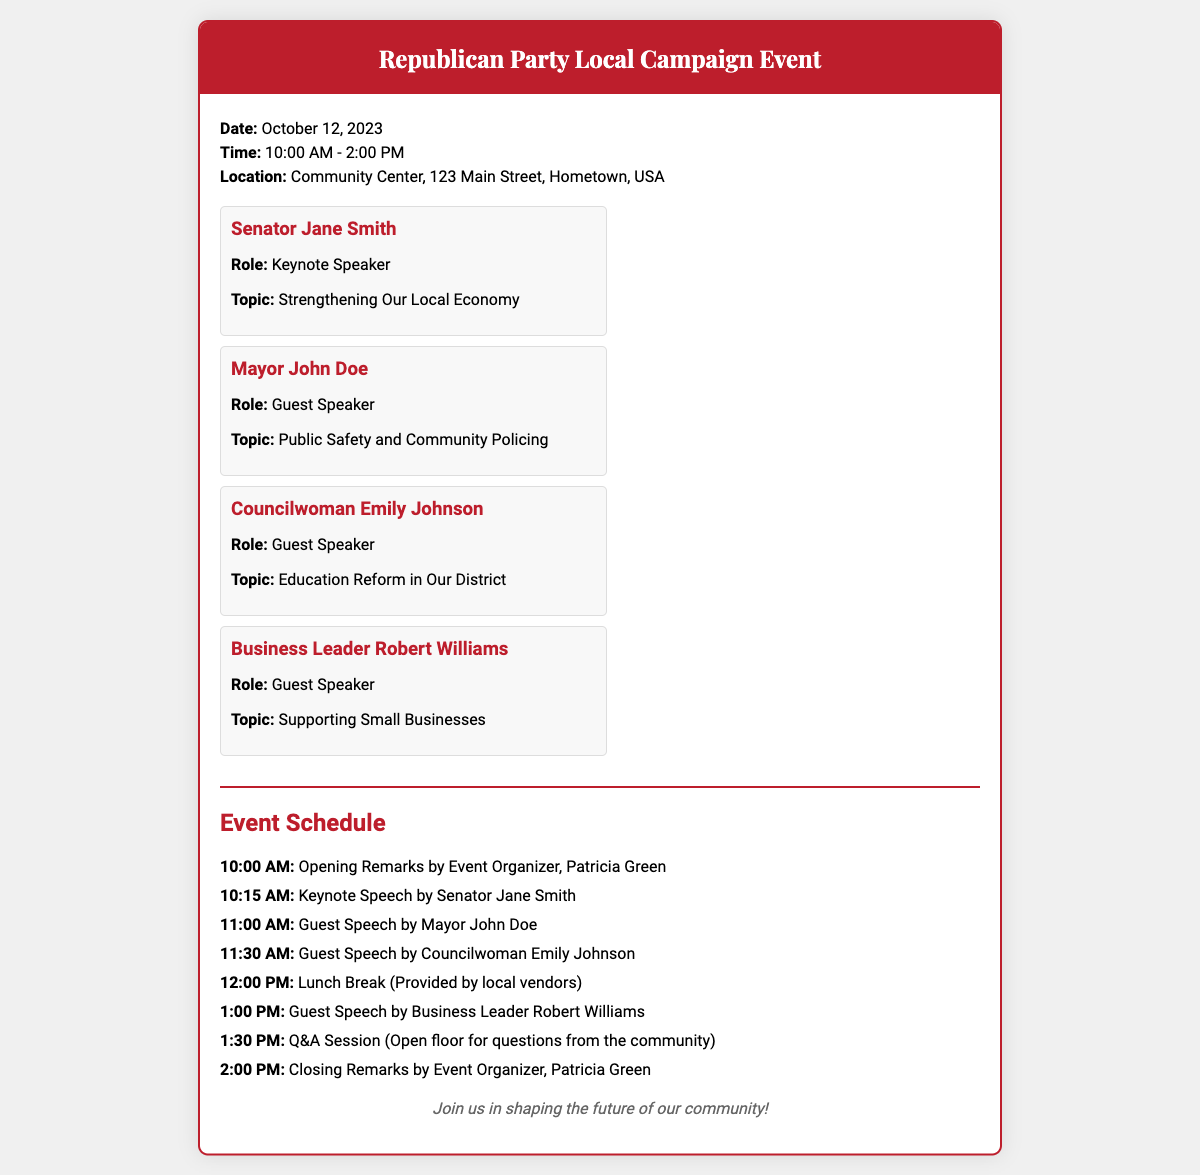What is the date of the event? The date is specified in the event details section of the document.
Answer: October 12, 2023 Who is the keynote speaker? The keynote speaker is listed among the speakers in the document.
Answer: Senator Jane Smith What time does the event start? The starting time is mentioned in the event details.
Answer: 10:00 AM How many guest speakers are listed? The total number of guest speakers can be counted from the speaker section in the document.
Answer: Three What is the topic of Senator Jane Smith's speech? The topic is included under the speaker's information.
Answer: Strengthening Our Local Economy What is provided during the lunch break? The details of the lunch break are mentioned in the event schedule.
Answer: Provided by local vendors What time is the Q&A session scheduled? The time for the Q&A session can be found in the event schedule section.
Answer: 1:30 PM Who will give the closing remarks? This information is stated in the event schedule under the closing remarks section.
Answer: Patricia Green What location is the event being held at? The location is mentioned in the event details of the document.
Answer: Community Center, 123 Main Street, Hometown, USA 